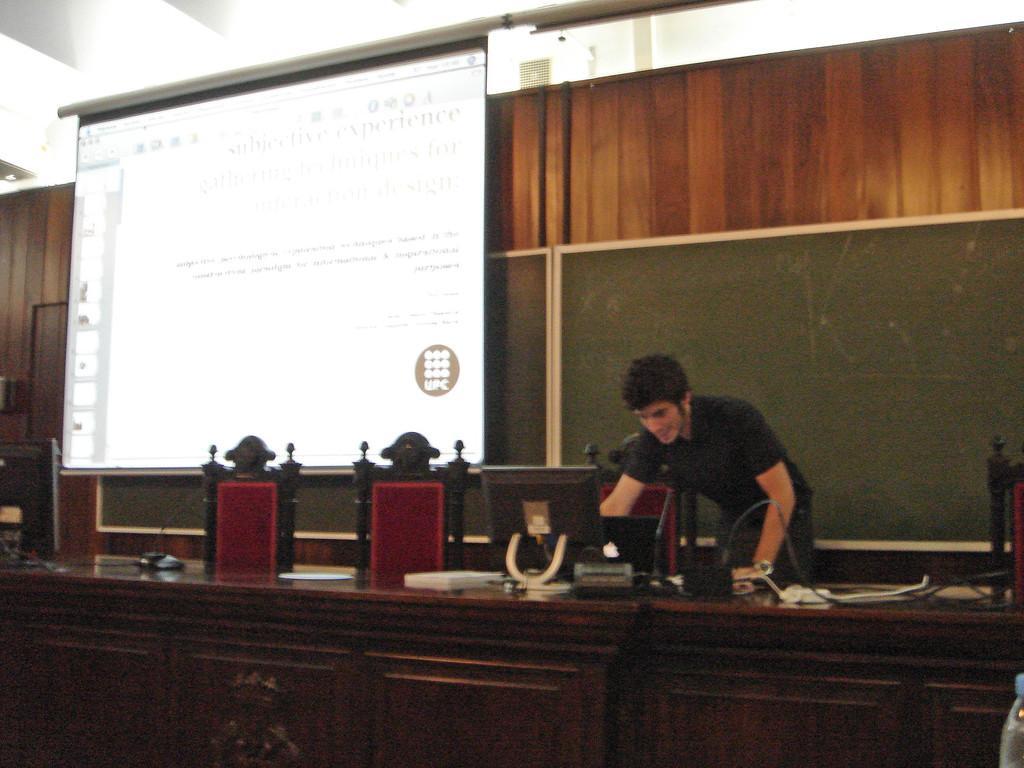Describe this image in one or two sentences. In this image we can see a person standing near the table, there is a system, laptop, mic´s and few other objects on the table and there are chairs near the table and in the background there is a presentation screen and boards attached to the wall. 